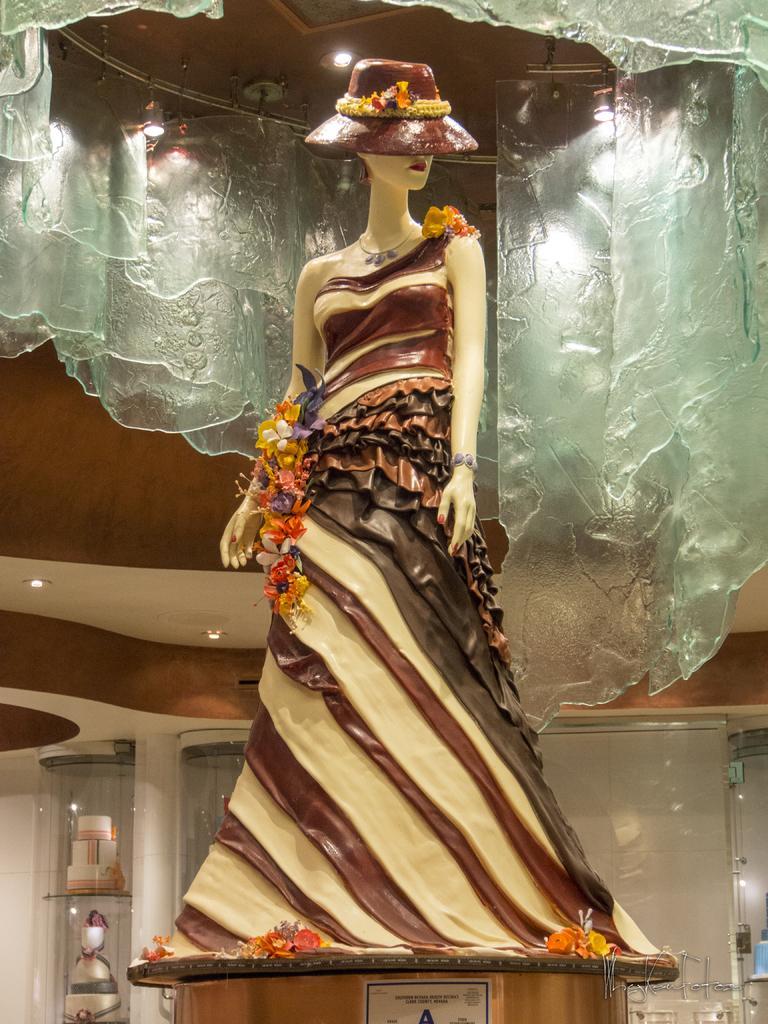Can you describe this image briefly? In this image I can see a doll is wearing different color dress. Back I can see inner part of the building,cakes and pillars. 